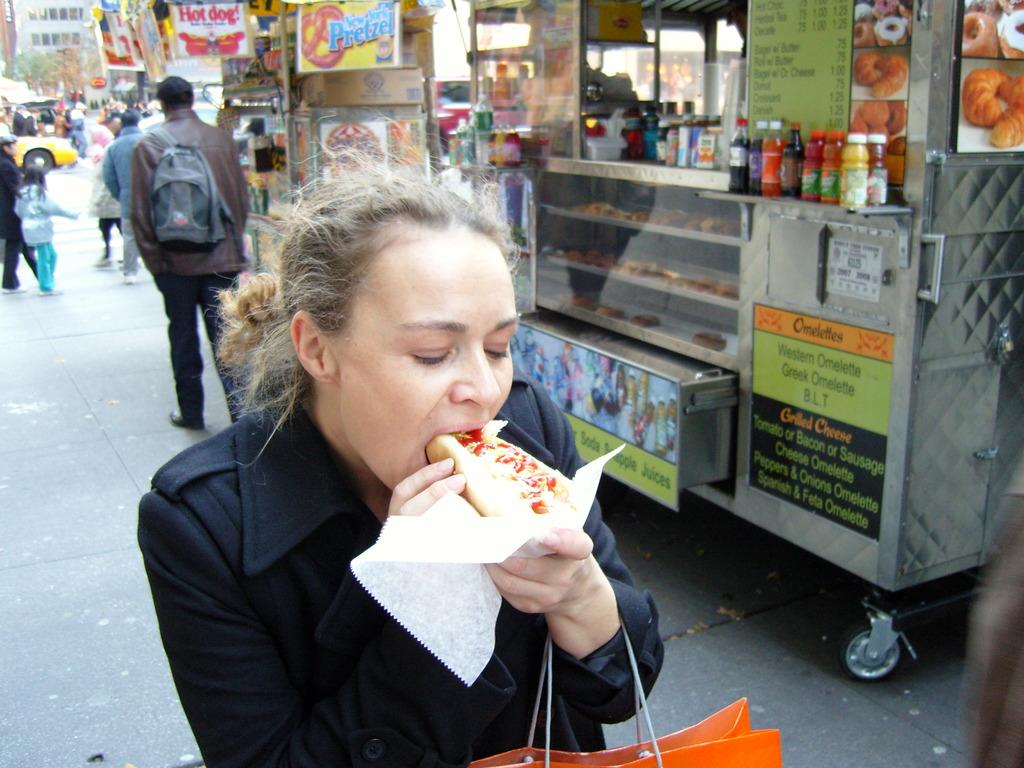What kind of omelettes are on the menu?
Offer a very short reply. Unanswerable. What is the first omelette being sold by the food truck?
Your response must be concise. Western omelette. 